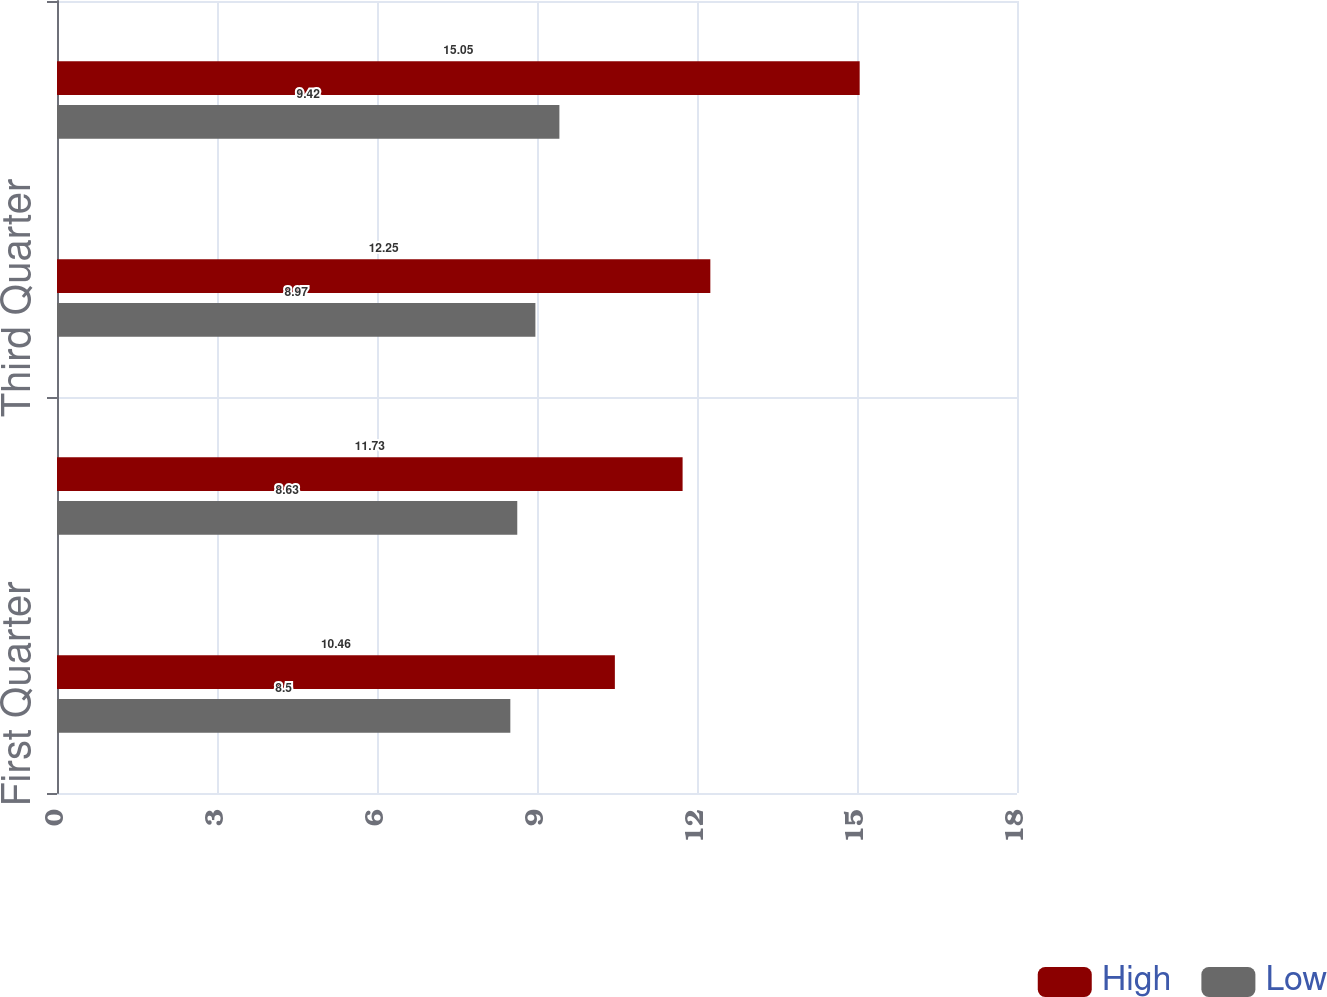Convert chart. <chart><loc_0><loc_0><loc_500><loc_500><stacked_bar_chart><ecel><fcel>First Quarter<fcel>Second Quarter<fcel>Third Quarter<fcel>Fourth Quarter<nl><fcel>High<fcel>10.46<fcel>11.73<fcel>12.25<fcel>15.05<nl><fcel>Low<fcel>8.5<fcel>8.63<fcel>8.97<fcel>9.42<nl></chart> 